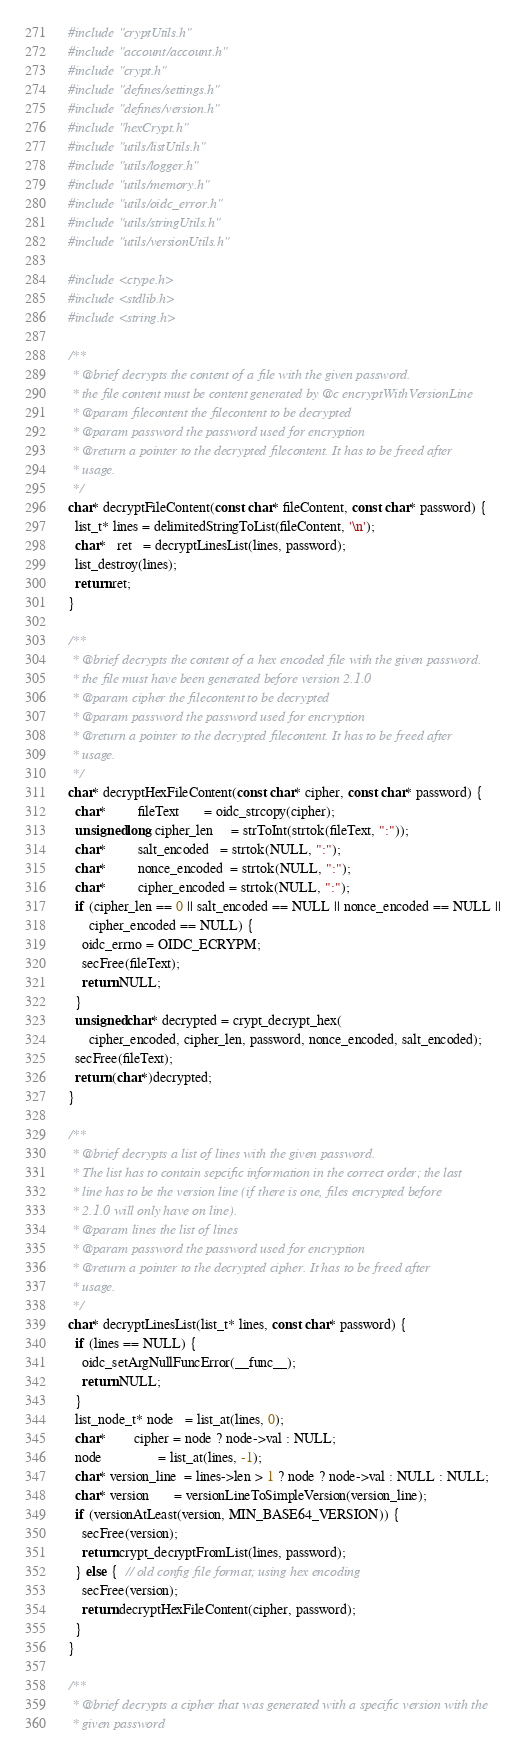<code> <loc_0><loc_0><loc_500><loc_500><_C_>#include "cryptUtils.h"
#include "account/account.h"
#include "crypt.h"
#include "defines/settings.h"
#include "defines/version.h"
#include "hexCrypt.h"
#include "utils/listUtils.h"
#include "utils/logger.h"
#include "utils/memory.h"
#include "utils/oidc_error.h"
#include "utils/stringUtils.h"
#include "utils/versionUtils.h"

#include <ctype.h>
#include <stdlib.h>
#include <string.h>

/**
 * @brief decrypts the content of a file with the given password.
 * the file content must be content generated by @c encryptWithVersionLine
 * @param filecontent the filecontent to be decrypted
 * @param password the password used for encryption
 * @return a pointer to the decrypted filecontent. It has to be freed after
 * usage.
 */
char* decryptFileContent(const char* fileContent, const char* password) {
  list_t* lines = delimitedStringToList(fileContent, '\n');
  char*   ret   = decryptLinesList(lines, password);
  list_destroy(lines);
  return ret;
}

/**
 * @brief decrypts the content of a hex encoded file with the given password.
 * the file must have been generated before version 2.1.0
 * @param cipher the filecontent to be decrypted
 * @param password the password used for encryption
 * @return a pointer to the decrypted filecontent. It has to be freed after
 * usage.
 */
char* decryptHexFileContent(const char* cipher, const char* password) {
  char*         fileText       = oidc_strcopy(cipher);
  unsigned long cipher_len     = strToInt(strtok(fileText, ":"));
  char*         salt_encoded   = strtok(NULL, ":");
  char*         nonce_encoded  = strtok(NULL, ":");
  char*         cipher_encoded = strtok(NULL, ":");
  if (cipher_len == 0 || salt_encoded == NULL || nonce_encoded == NULL ||
      cipher_encoded == NULL) {
    oidc_errno = OIDC_ECRYPM;
    secFree(fileText);
    return NULL;
  }
  unsigned char* decrypted = crypt_decrypt_hex(
      cipher_encoded, cipher_len, password, nonce_encoded, salt_encoded);
  secFree(fileText);
  return (char*)decrypted;
}

/**
 * @brief decrypts a list of lines with the given password.
 * The list has to contain sepcific information in the correct order; the last
 * line has to be the version line (if there is one, files encrypted before
 * 2.1.0 will only have on line).
 * @param lines the list of lines
 * @param password the password used for encryption
 * @return a pointer to the decrypted cipher. It has to be freed after
 * usage.
 */
char* decryptLinesList(list_t* lines, const char* password) {
  if (lines == NULL) {
    oidc_setArgNullFuncError(__func__);
    return NULL;
  }
  list_node_t* node   = list_at(lines, 0);
  char*        cipher = node ? node->val : NULL;
  node                = list_at(lines, -1);
  char* version_line  = lines->len > 1 ? node ? node->val : NULL : NULL;
  char* version       = versionLineToSimpleVersion(version_line);
  if (versionAtLeast(version, MIN_BASE64_VERSION)) {
    secFree(version);
    return crypt_decryptFromList(lines, password);
  } else {  // old config file format; using hex encoding
    secFree(version);
    return decryptHexFileContent(cipher, password);
  }
}

/**
 * @brief decrypts a cipher that was generated with a specific version with the
 * given password</code> 